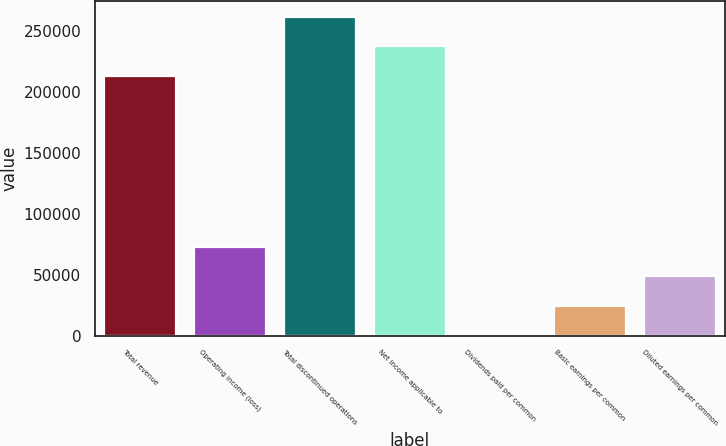Convert chart to OTSL. <chart><loc_0><loc_0><loc_500><loc_500><bar_chart><fcel>Total revenue<fcel>Operating income (loss)<fcel>Total discontinued operations<fcel>Net income applicable to<fcel>Dividends paid per common<fcel>Basic earnings per common<fcel>Diluted earnings per common<nl><fcel>212758<fcel>73006.8<fcel>261429<fcel>237093<fcel>0.42<fcel>24335.9<fcel>48671.3<nl></chart> 